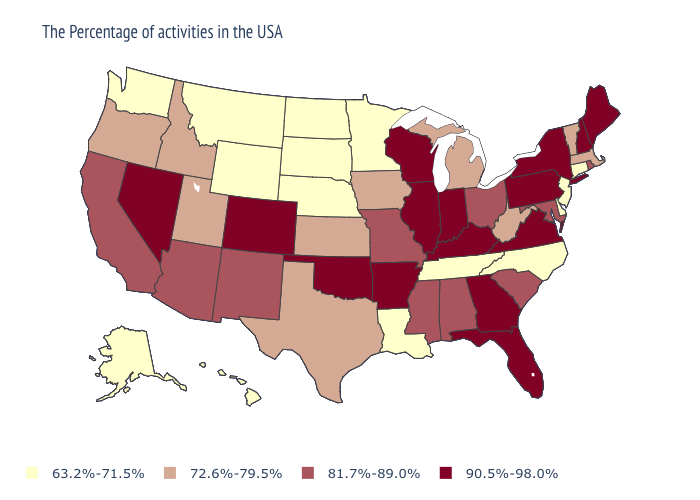Name the states that have a value in the range 90.5%-98.0%?
Concise answer only. Maine, New Hampshire, New York, Pennsylvania, Virginia, Florida, Georgia, Kentucky, Indiana, Wisconsin, Illinois, Arkansas, Oklahoma, Colorado, Nevada. How many symbols are there in the legend?
Keep it brief. 4. Does Wyoming have the lowest value in the USA?
Keep it brief. Yes. Among the states that border Connecticut , which have the lowest value?
Concise answer only. Massachusetts. Does Montana have the highest value in the USA?
Answer briefly. No. What is the value of Arkansas?
Keep it brief. 90.5%-98.0%. Which states have the lowest value in the USA?
Concise answer only. Connecticut, New Jersey, Delaware, North Carolina, Tennessee, Louisiana, Minnesota, Nebraska, South Dakota, North Dakota, Wyoming, Montana, Washington, Alaska, Hawaii. Among the states that border North Carolina , which have the lowest value?
Give a very brief answer. Tennessee. Name the states that have a value in the range 63.2%-71.5%?
Give a very brief answer. Connecticut, New Jersey, Delaware, North Carolina, Tennessee, Louisiana, Minnesota, Nebraska, South Dakota, North Dakota, Wyoming, Montana, Washington, Alaska, Hawaii. Among the states that border New York , does Connecticut have the lowest value?
Concise answer only. Yes. What is the lowest value in states that border Rhode Island?
Short answer required. 63.2%-71.5%. What is the value of Massachusetts?
Short answer required. 72.6%-79.5%. Does Wisconsin have the lowest value in the MidWest?
Quick response, please. No. Is the legend a continuous bar?
Give a very brief answer. No. What is the value of South Carolina?
Answer briefly. 81.7%-89.0%. 